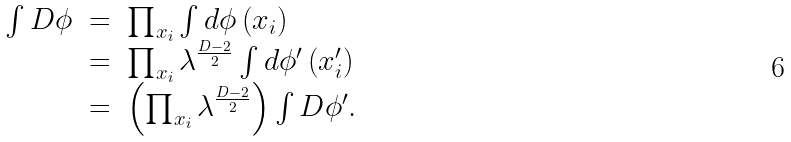<formula> <loc_0><loc_0><loc_500><loc_500>\begin{array} { r c l } \int D \phi & = & \prod _ { x _ { i } } \int d \phi \left ( x _ { i } \right ) \\ & = & \prod _ { x _ { i } } \lambda ^ { \frac { D - 2 } { 2 } } \int d \phi ^ { \prime } \left ( x ^ { \prime } _ { i } \right ) \\ & = & \left ( \prod _ { x _ { i } } \lambda ^ { \frac { D - 2 } { 2 } } \right ) \int D \phi ^ { \prime } . \end{array}</formula> 